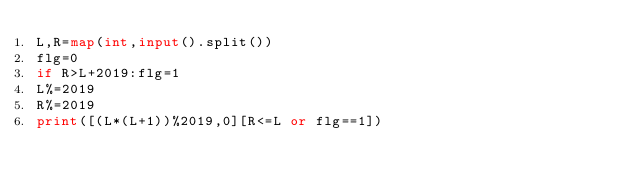Convert code to text. <code><loc_0><loc_0><loc_500><loc_500><_Python_>L,R=map(int,input().split())
flg=0
if R>L+2019:flg=1
L%=2019
R%=2019
print([(L*(L+1))%2019,0][R<=L or flg==1])</code> 